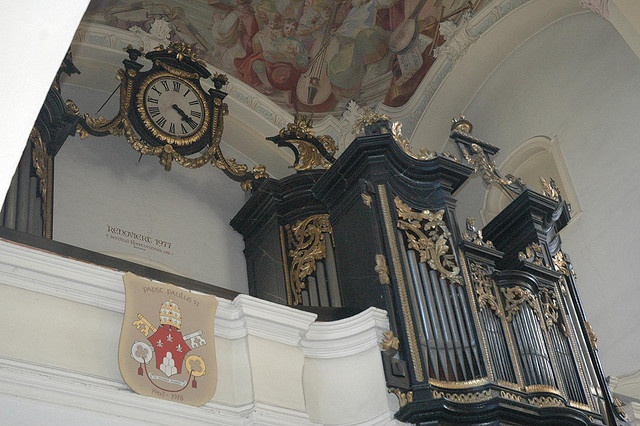Describe the objects in this image and their specific colors. I can see a clock in white, black, and gray tones in this image. 